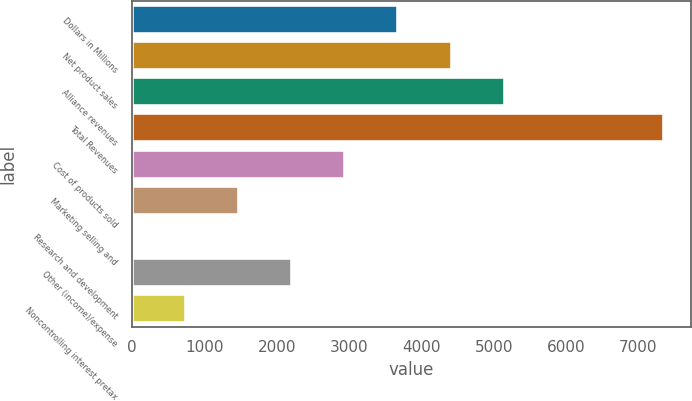Convert chart. <chart><loc_0><loc_0><loc_500><loc_500><bar_chart><fcel>Dollars in Millions<fcel>Net product sales<fcel>Alliance revenues<fcel>Total Revenues<fcel>Cost of products sold<fcel>Marketing selling and<fcel>Research and development<fcel>Other (income)/expense<fcel>Noncontrolling interest pretax<nl><fcel>3683.5<fcel>4418.6<fcel>5153.7<fcel>7359<fcel>2948.4<fcel>1478.2<fcel>8<fcel>2213.3<fcel>743.1<nl></chart> 